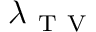<formula> <loc_0><loc_0><loc_500><loc_500>\lambda _ { T V }</formula> 